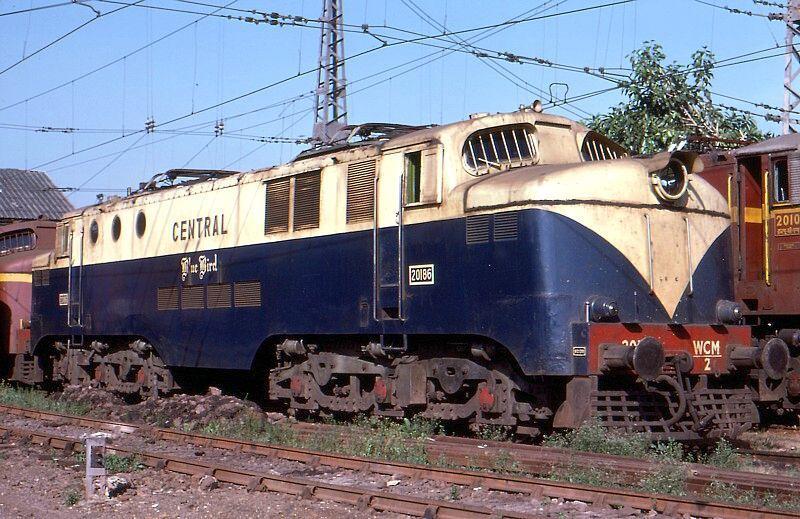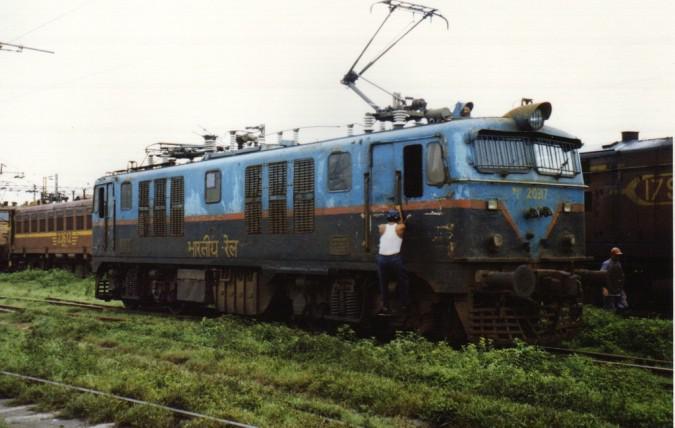The first image is the image on the left, the second image is the image on the right. Assess this claim about the two images: "The top of one of the trains is blue.". Correct or not? Answer yes or no. Yes. 